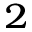<formula> <loc_0><loc_0><loc_500><loc_500>^ { 2 }</formula> 